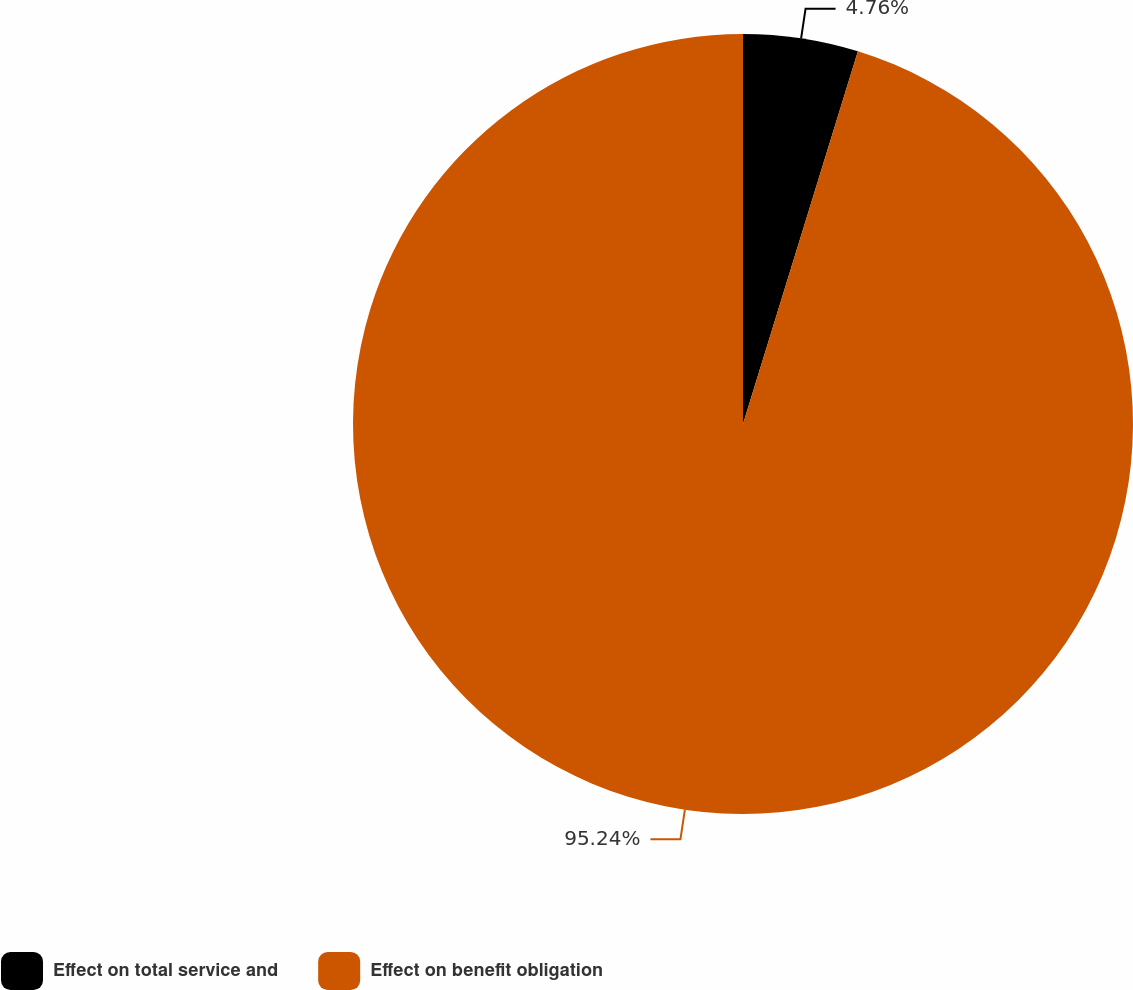<chart> <loc_0><loc_0><loc_500><loc_500><pie_chart><fcel>Effect on total service and<fcel>Effect on benefit obligation<nl><fcel>4.76%<fcel>95.24%<nl></chart> 